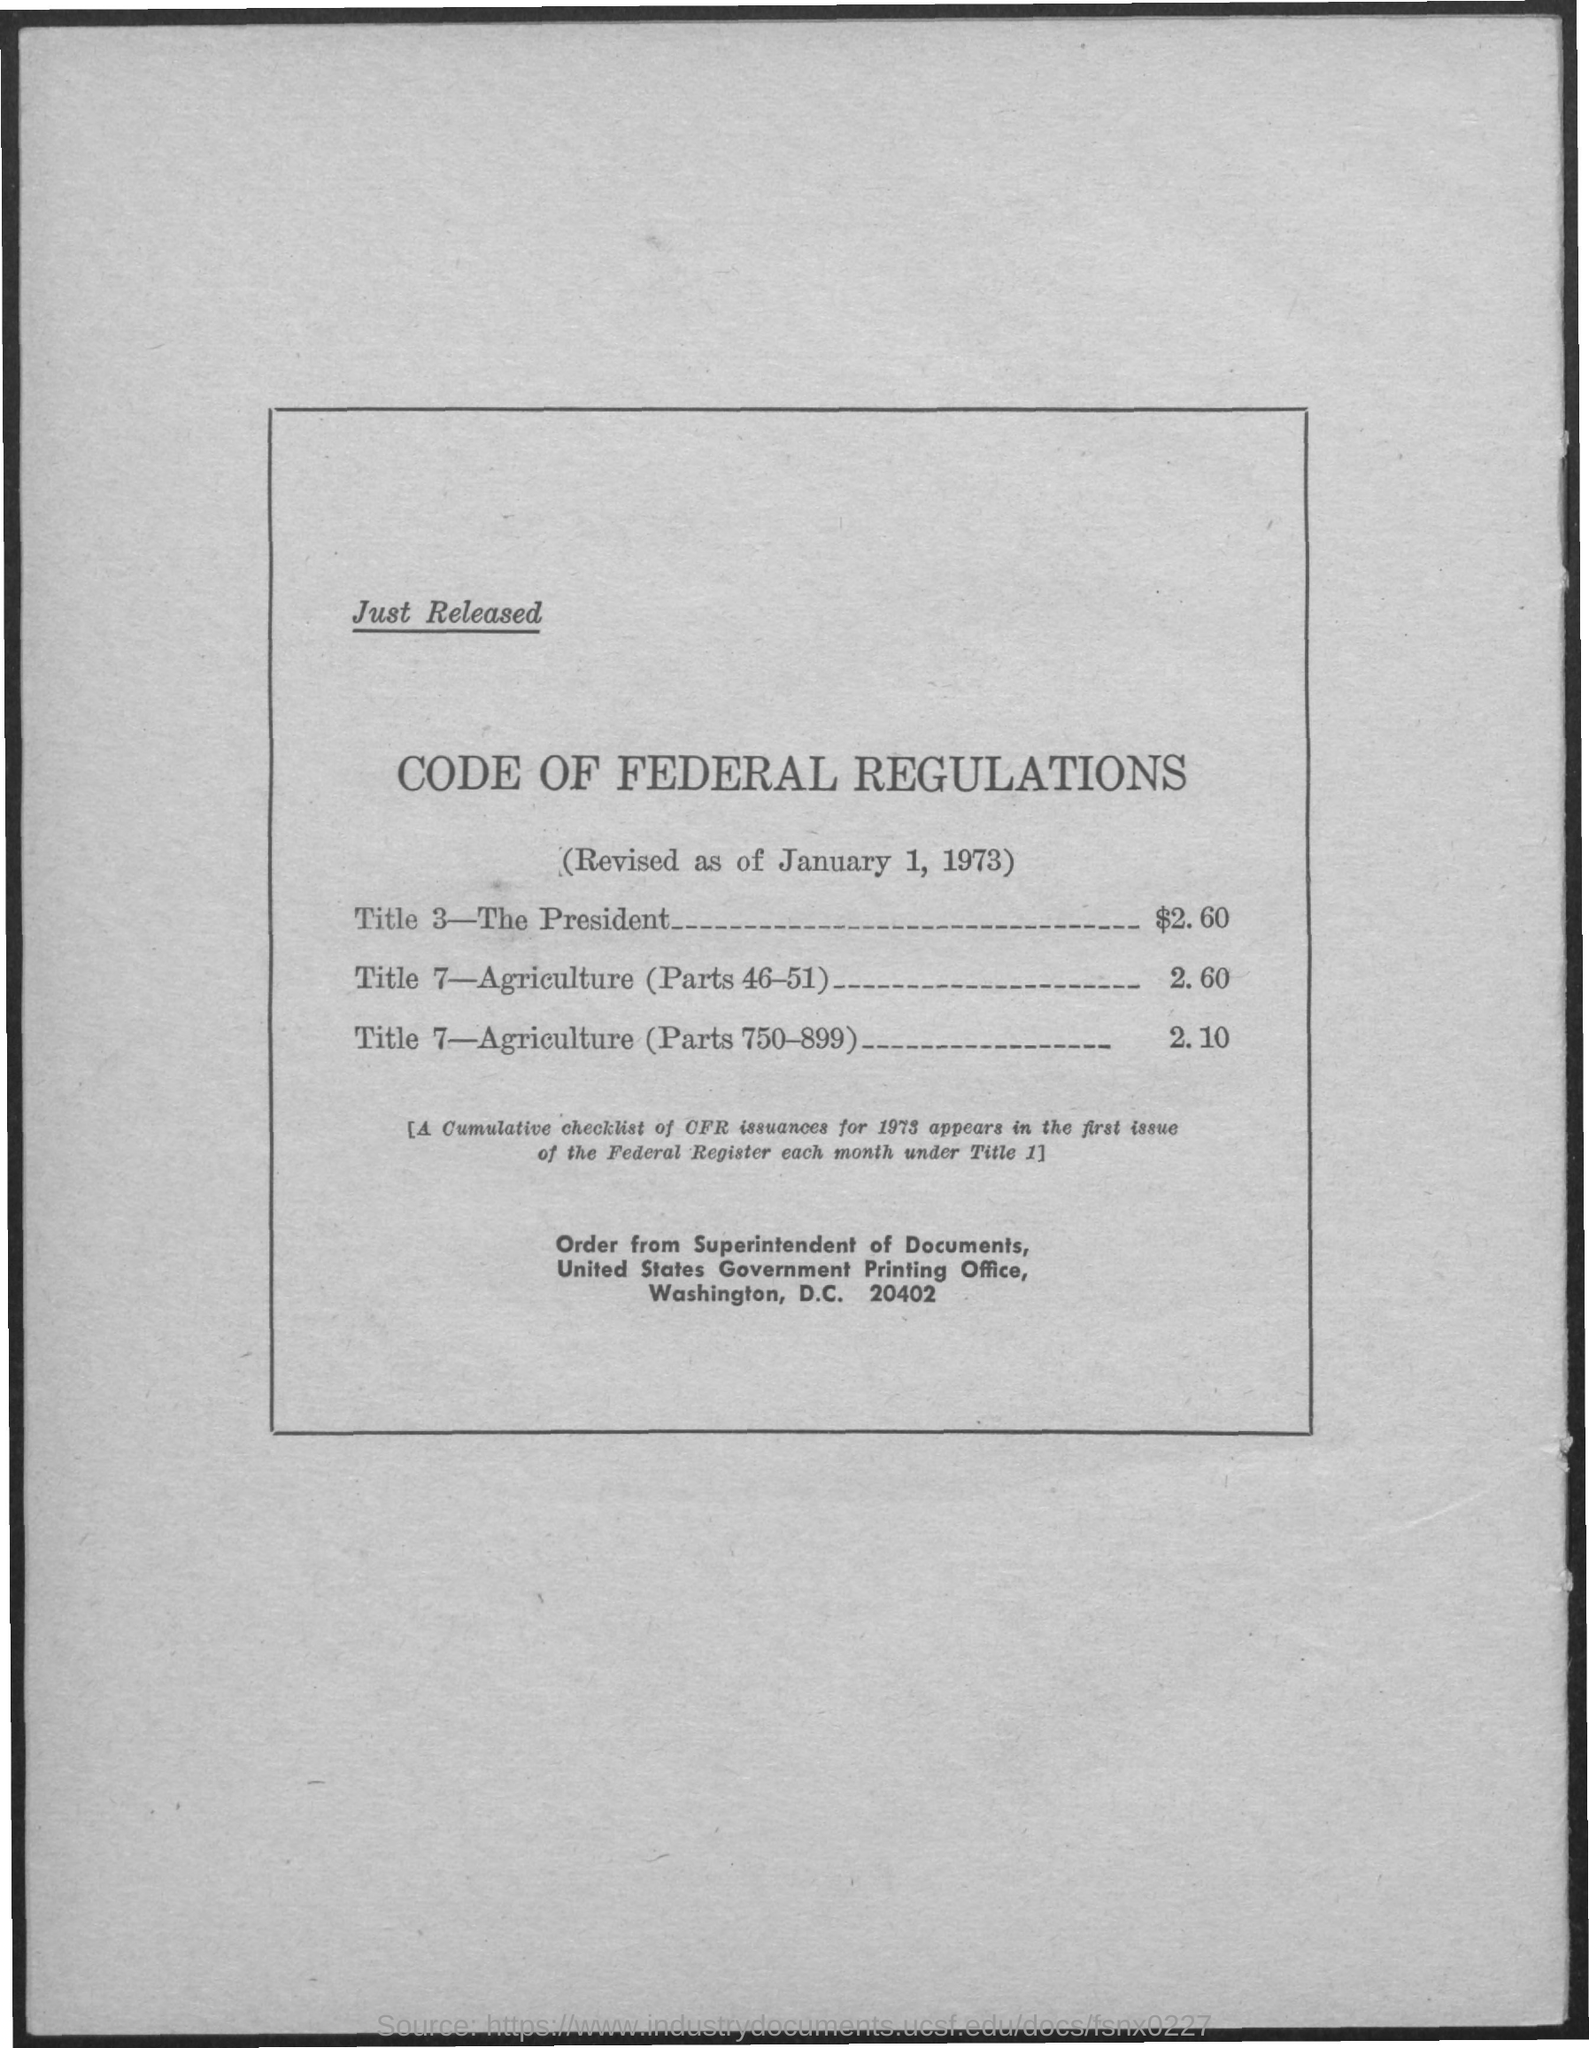Highlight a few significant elements in this photo. Title 7 of the Code of Federal Regulations, which covers agriculture, includes sections 46-51. The cost of these regulations is 2.60. The Superintendent of Documents is the appropriate entity to whom orders should be directed. The cost of Title 7, which covers agriculture (sections 750-899), is 2.10. The document indicates that the date is January 1, 1973. The cost of Title 3 is $2.60. 